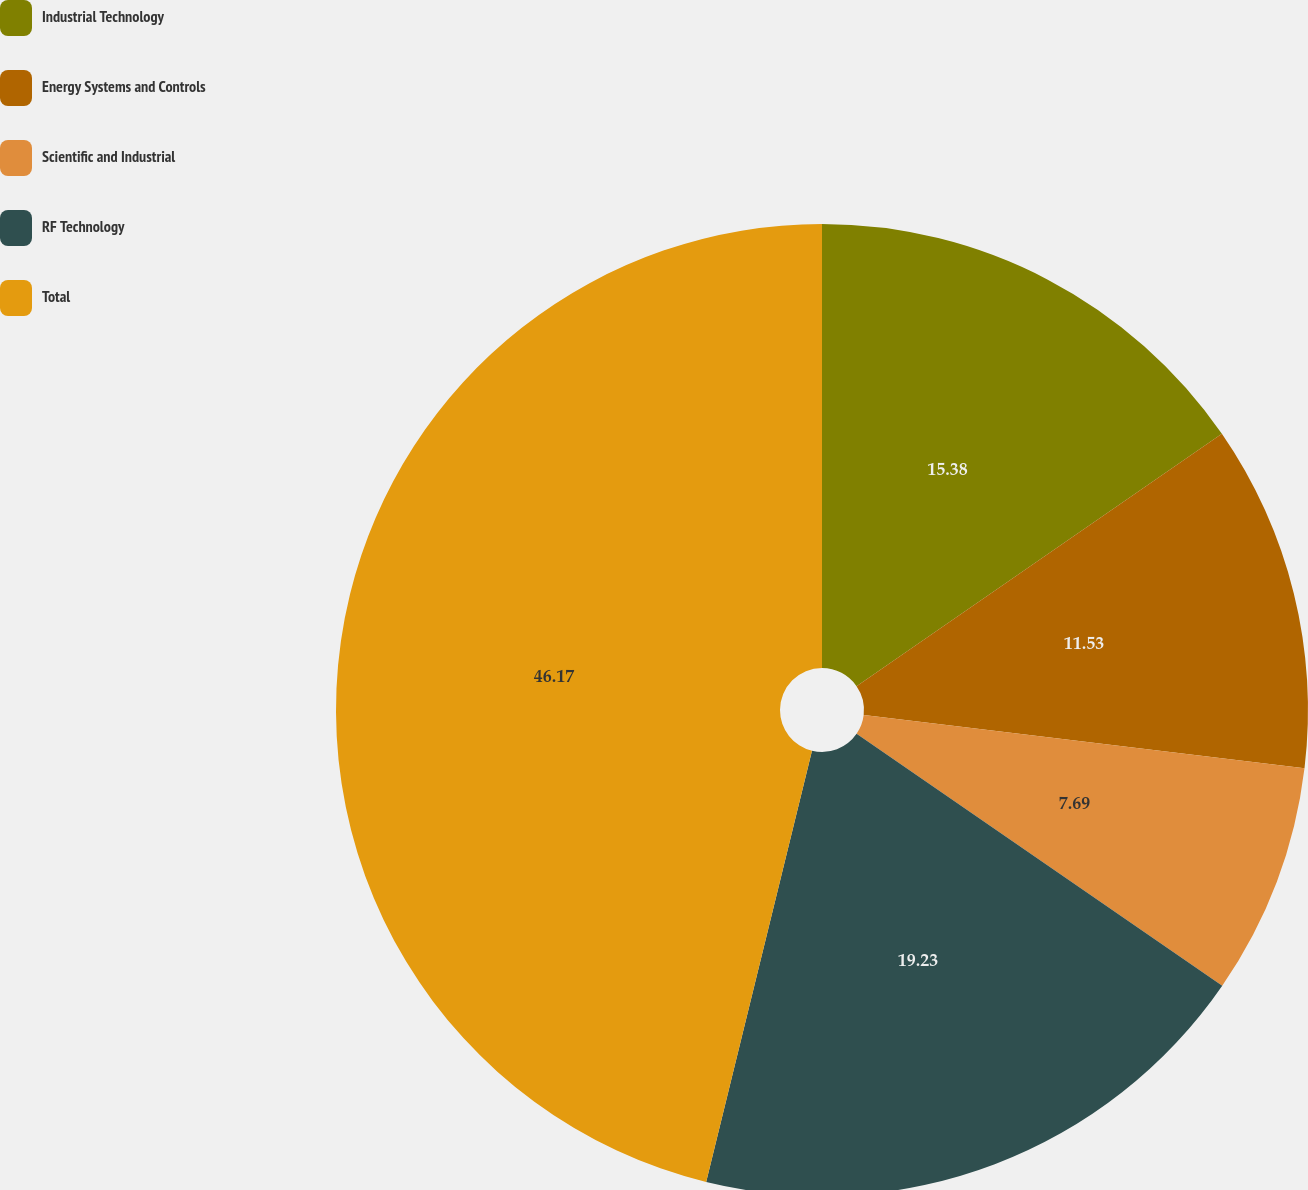Convert chart to OTSL. <chart><loc_0><loc_0><loc_500><loc_500><pie_chart><fcel>Industrial Technology<fcel>Energy Systems and Controls<fcel>Scientific and Industrial<fcel>RF Technology<fcel>Total<nl><fcel>15.38%<fcel>11.53%<fcel>7.69%<fcel>19.23%<fcel>46.17%<nl></chart> 